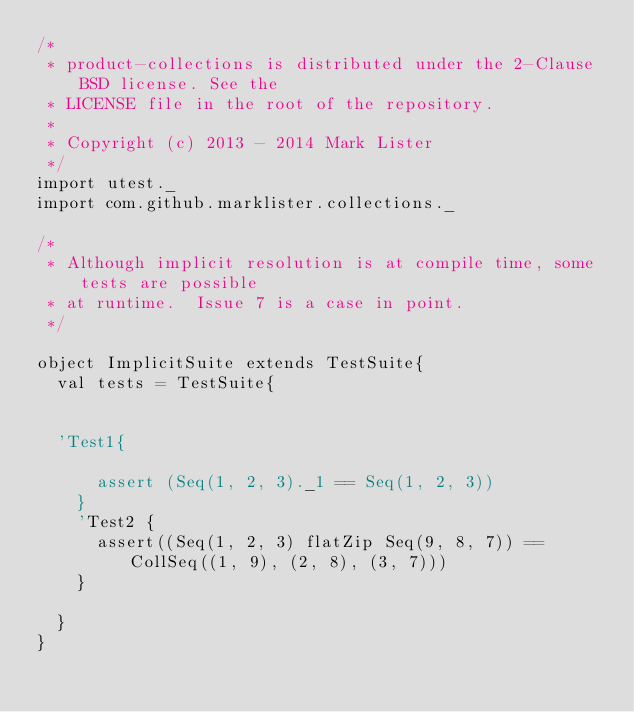Convert code to text. <code><loc_0><loc_0><loc_500><loc_500><_Scala_>/*
 * product-collections is distributed under the 2-Clause BSD license. See the
 * LICENSE file in the root of the repository.
 *
 * Copyright (c) 2013 - 2014 Mark Lister
 */
import utest._
import com.github.marklister.collections._

/* 
 * Although implicit resolution is at compile time, some tests are possible
 * at runtime.  Issue 7 is a case in point.
 */

object ImplicitSuite extends TestSuite{
  val tests = TestSuite{


  'Test1{

      assert (Seq(1, 2, 3)._1 == Seq(1, 2, 3))
    }
    'Test2 {
      assert((Seq(1, 2, 3) flatZip Seq(9, 8, 7)) == CollSeq((1, 9), (2, 8), (3, 7)))
    }

  }
}</code> 